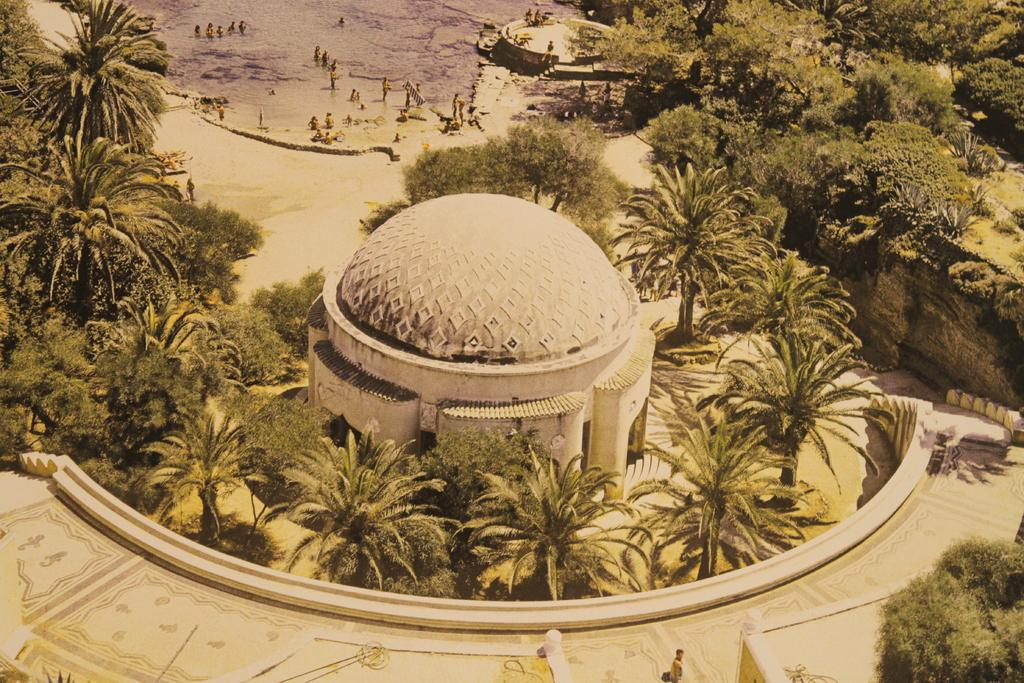What type of vegetation can be seen in the image? There are trees in the image. What type of structure is present in the image? There is a dome in the image. Are there any people in the image? Yes, there are persons in the image. What is the ground covered with in the image? There is grass on the ground in the image. What natural element can be seen in the image? There is water visible in the image. Can you tell me how many uncles are sitting on the sheet in the image? There is no sheet or uncle present in the image. Are there any giants visible in the image? There are no giants present in the image. 